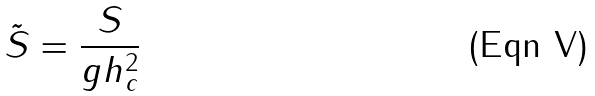<formula> <loc_0><loc_0><loc_500><loc_500>\tilde { S } = \frac { S } { g h _ { c } ^ { 2 } }</formula> 